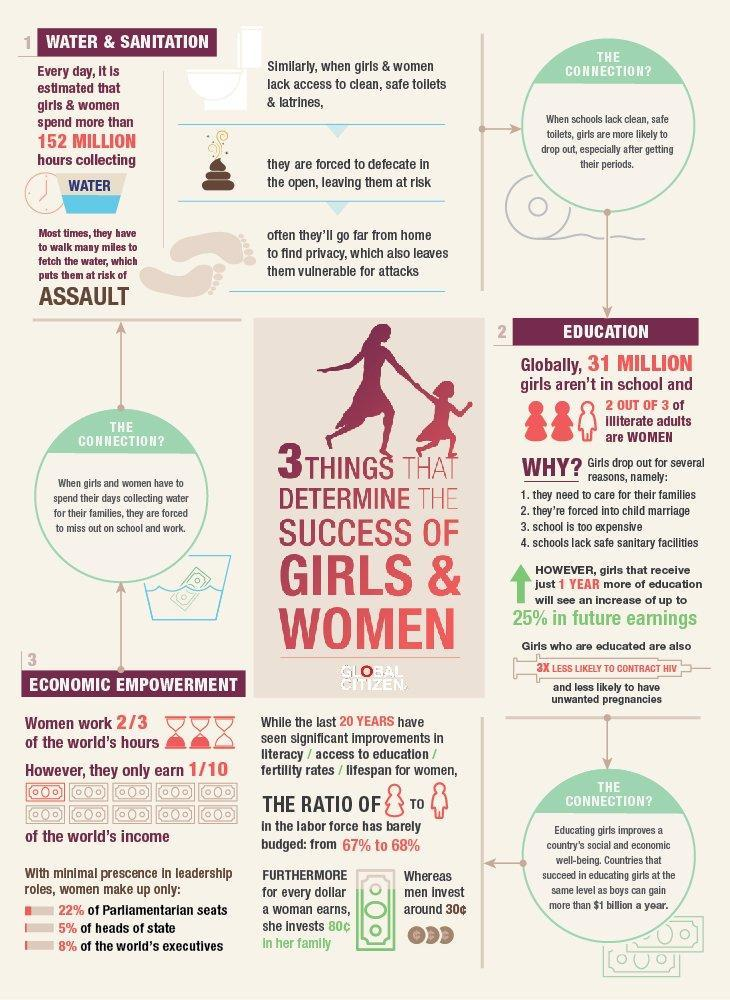What can help to increase a girl's future earnings by 25%?
Answer the question with a short phrase. 1 year more of education How much do men invest per dollar of earning in his family? 30c 152 million hours are spent by girls and women for the collection of what substance? water Who earn only 1/10 of world's income? women 